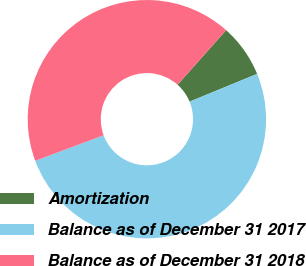Convert chart. <chart><loc_0><loc_0><loc_500><loc_500><pie_chart><fcel>Amortization<fcel>Balance as of December 31 2017<fcel>Balance as of December 31 2018<nl><fcel>7.22%<fcel>50.53%<fcel>42.25%<nl></chart> 